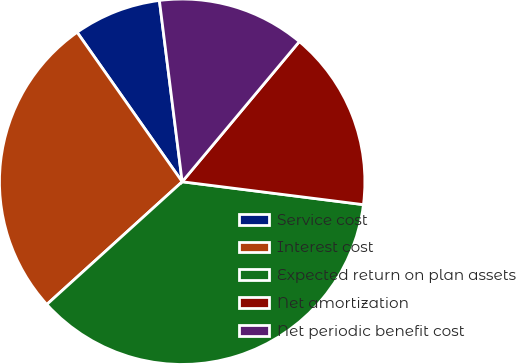<chart> <loc_0><loc_0><loc_500><loc_500><pie_chart><fcel>Service cost<fcel>Interest cost<fcel>Expected return on plan assets<fcel>Net amortization<fcel>Net periodic benefit cost<nl><fcel>7.76%<fcel>26.97%<fcel>36.28%<fcel>15.92%<fcel>13.07%<nl></chart> 